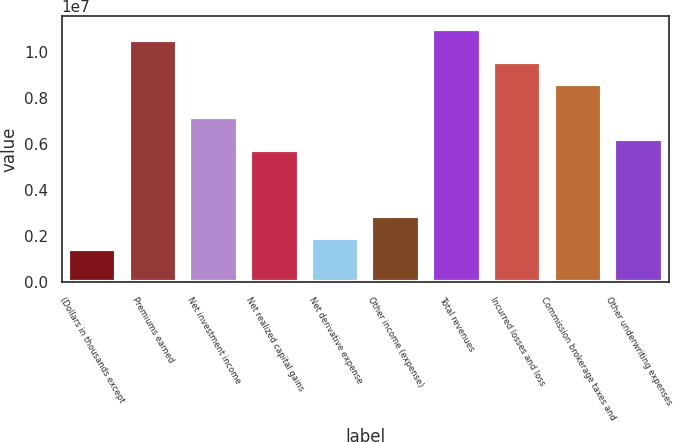<chart> <loc_0><loc_0><loc_500><loc_500><bar_chart><fcel>(Dollars in thousands except<fcel>Premiums earned<fcel>Net investment income<fcel>Net realized capital gains<fcel>Net derivative expense<fcel>Other income (expense)<fcel>Total revenues<fcel>Incurred losses and loss<fcel>Commission brokerage taxes and<fcel>Other underwriting expenses<nl><fcel>1.43462e+06<fcel>1.05205e+07<fcel>7.17306e+06<fcel>5.73845e+06<fcel>1.91283e+06<fcel>2.86923e+06<fcel>1.09987e+07<fcel>9.56408e+06<fcel>8.60767e+06<fcel>6.21666e+06<nl></chart> 